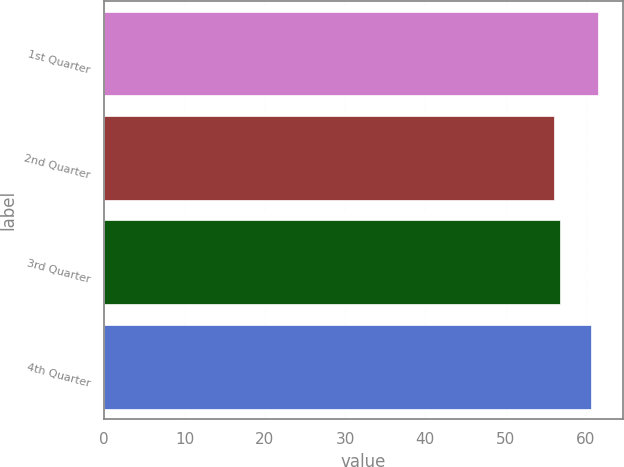Convert chart. <chart><loc_0><loc_0><loc_500><loc_500><bar_chart><fcel>1st Quarter<fcel>2nd Quarter<fcel>3rd Quarter<fcel>4th Quarter<nl><fcel>61.53<fcel>56.01<fcel>56.77<fcel>60.7<nl></chart> 